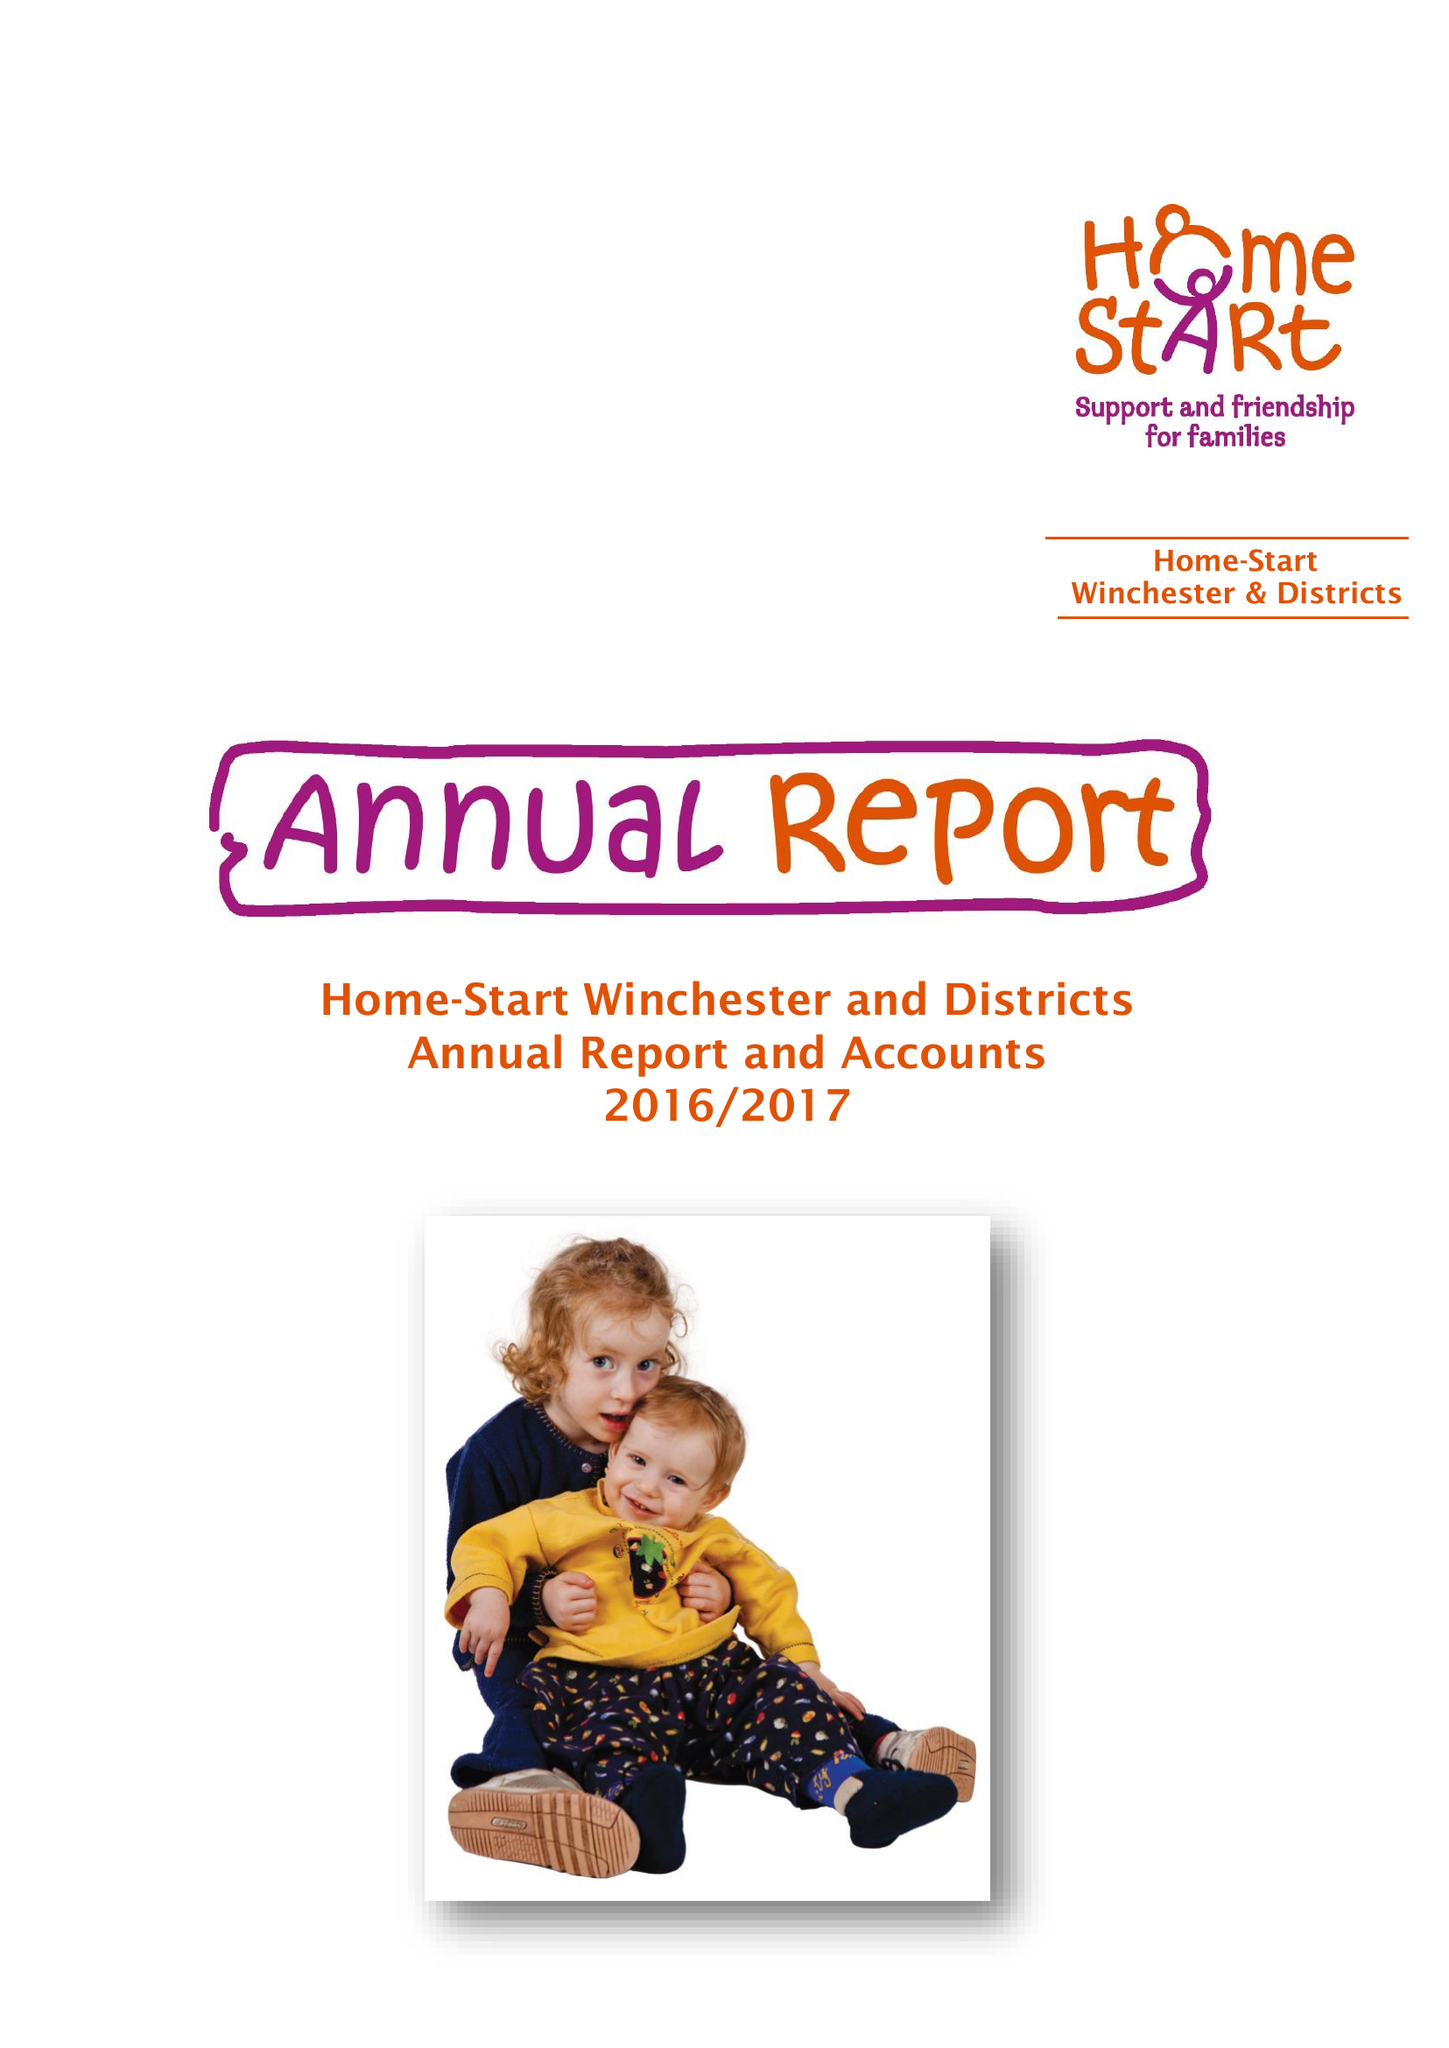What is the value for the charity_name?
Answer the question using a single word or phrase. Home-Start Winchester and Districts 